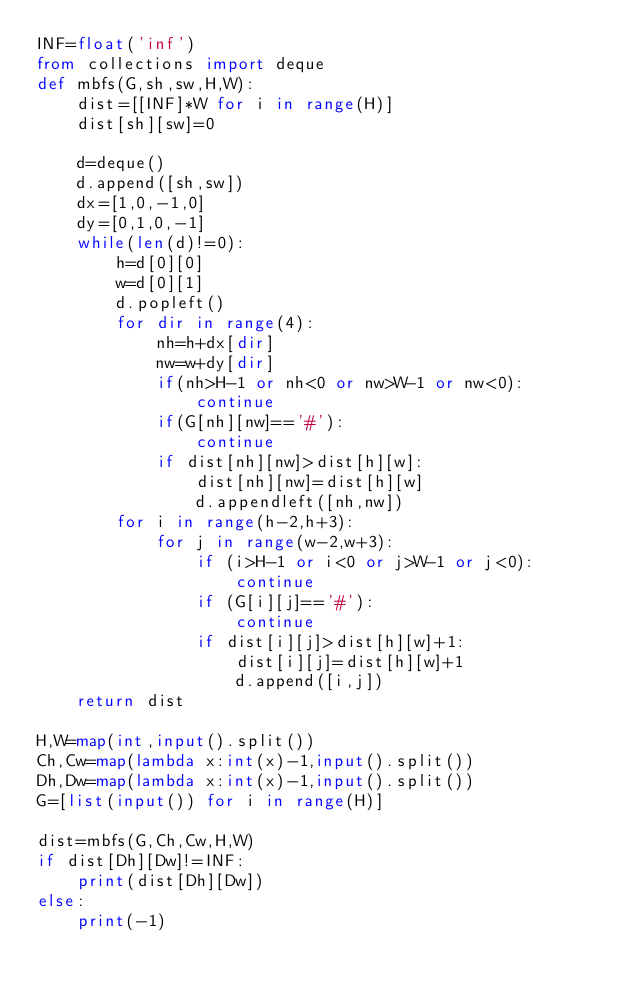Convert code to text. <code><loc_0><loc_0><loc_500><loc_500><_Python_>INF=float('inf')
from collections import deque
def mbfs(G,sh,sw,H,W):
    dist=[[INF]*W for i in range(H)]
    dist[sh][sw]=0

    d=deque()
    d.append([sh,sw])
    dx=[1,0,-1,0]
    dy=[0,1,0,-1]
    while(len(d)!=0):
        h=d[0][0]
        w=d[0][1]
        d.popleft()
        for dir in range(4):
            nh=h+dx[dir]
            nw=w+dy[dir]
            if(nh>H-1 or nh<0 or nw>W-1 or nw<0):
                continue
            if(G[nh][nw]=='#'):
                continue
            if dist[nh][nw]>dist[h][w]:
                dist[nh][nw]=dist[h][w]
                d.appendleft([nh,nw])
        for i in range(h-2,h+3):
            for j in range(w-2,w+3):
                if (i>H-1 or i<0 or j>W-1 or j<0):
                    continue
                if (G[i][j]=='#'):
                    continue
                if dist[i][j]>dist[h][w]+1:
                    dist[i][j]=dist[h][w]+1
                    d.append([i,j])
    return dist

H,W=map(int,input().split())
Ch,Cw=map(lambda x:int(x)-1,input().split())
Dh,Dw=map(lambda x:int(x)-1,input().split())
G=[list(input()) for i in range(H)]

dist=mbfs(G,Ch,Cw,H,W)
if dist[Dh][Dw]!=INF:
    print(dist[Dh][Dw])
else:
    print(-1)</code> 